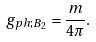<formula> <loc_0><loc_0><loc_500><loc_500>g _ { p h ; B _ { 2 } } = \frac { m } { 4 \pi } .</formula> 